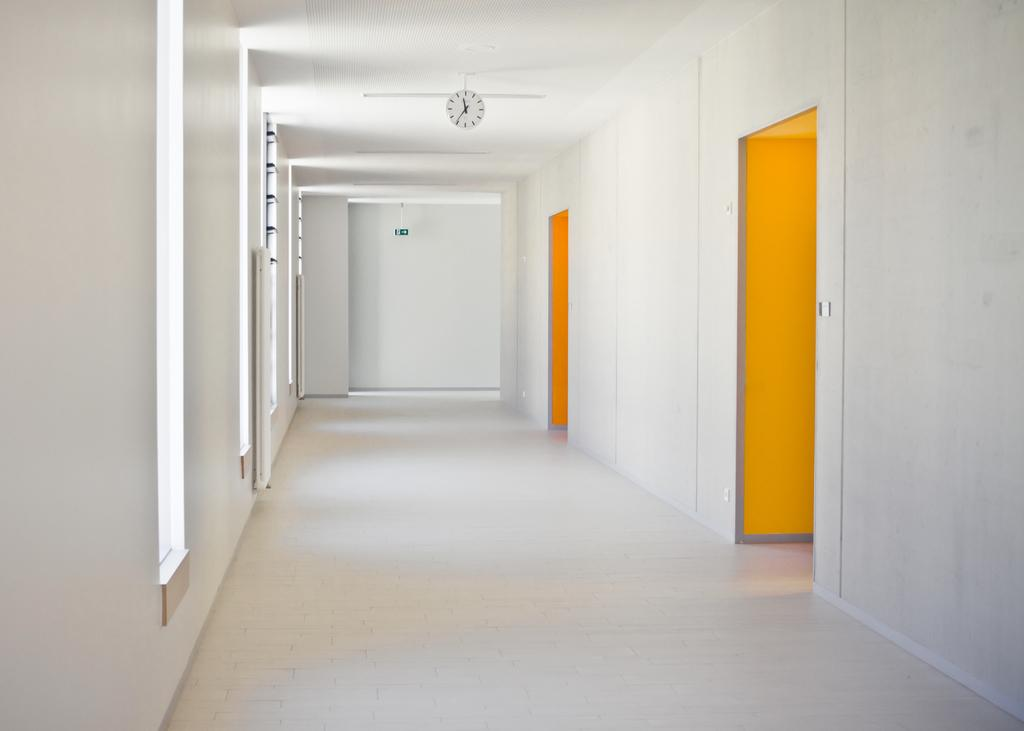What type of location is depicted in the image? The image shows an inside view of a building. Can you describe the layout of the building in the image? There are rooms visible in the image. What time-telling device is present in the image? There is a clock in the image. How can one enter or exit the rooms in the image? There is a door in the image. What type of attraction is present in the image? There is no attraction present in the image; it shows an inside view of a building with rooms, a clock, and a door. 